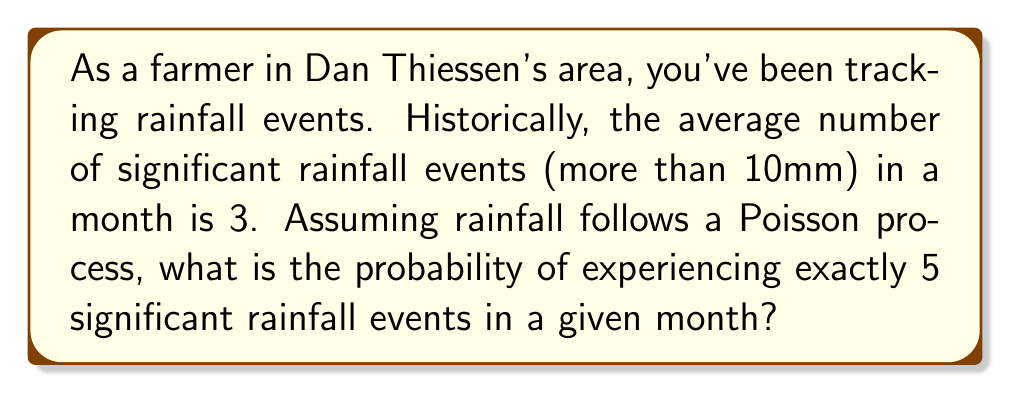Show me your answer to this math problem. Let's approach this step-by-step using the Poisson distribution:

1) The Poisson distribution is given by the formula:

   $$P(X = k) = \frac{e^{-\lambda} \lambda^k}{k!}$$

   where:
   - $\lambda$ is the average rate of events in the given interval
   - $k$ is the number of events we're interested in
   - $e$ is Euler's number (approximately 2.71828)

2) In this case:
   - $\lambda = 3$ (average of 3 significant rainfall events per month)
   - $k = 5$ (we're interested in exactly 5 events)

3) Let's substitute these values into the formula:

   $$P(X = 5) = \frac{e^{-3} 3^5}{5!}$$

4) Now, let's calculate step by step:

   a) First, $e^{-3} \approx 0.0497871$

   b) $3^5 = 243$

   c) $5! = 5 \times 4 \times 3 \times 2 \times 1 = 120$

5) Putting it all together:

   $$P(X = 5) = \frac{0.0497871 \times 243}{120} \approx 0.1008$$

6) Converting to a percentage: $0.1008 \times 100\% = 10.08\%$

Therefore, the probability of experiencing exactly 5 significant rainfall events in a given month is approximately 10.08%.
Answer: 10.08% 